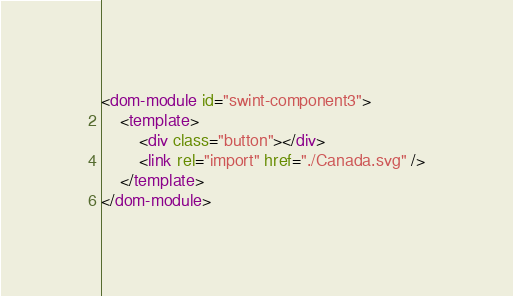Convert code to text. <code><loc_0><loc_0><loc_500><loc_500><_HTML_><dom-module id="swint-component3">
	<template>
		<div class="button"></div>
		<link rel="import" href="./Canada.svg" />
	</template>
</dom-module>
</code> 